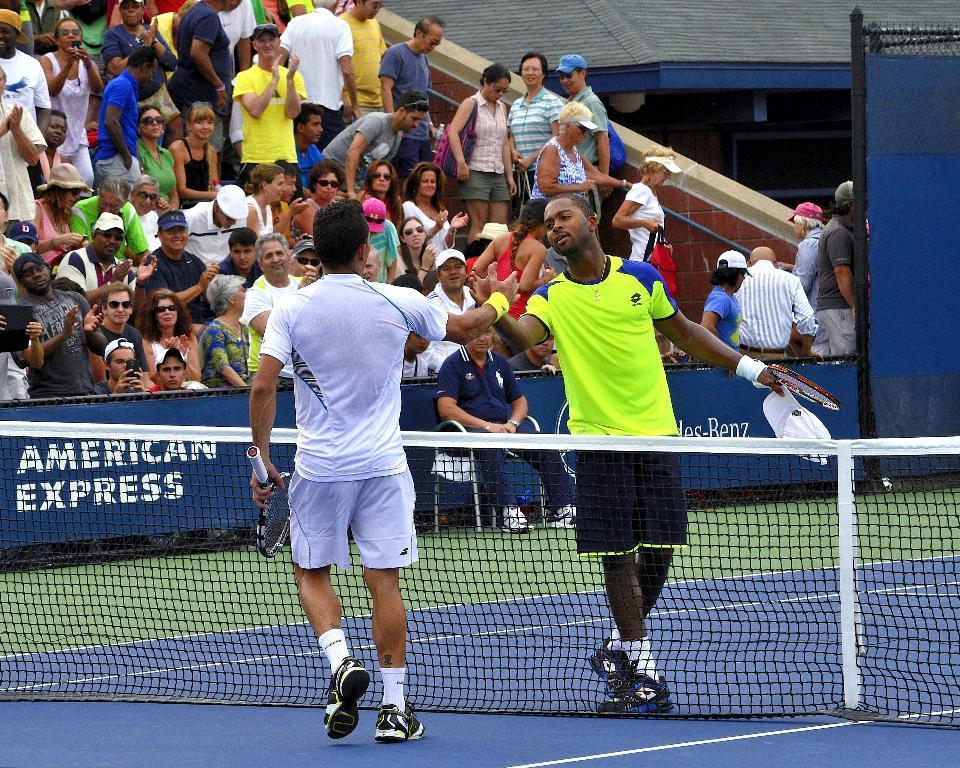Could you give a brief overview of what you see in this image? There are two people walking and holding rackets,in between these two people we can see net. Background we can see hoarding and these are audience. 